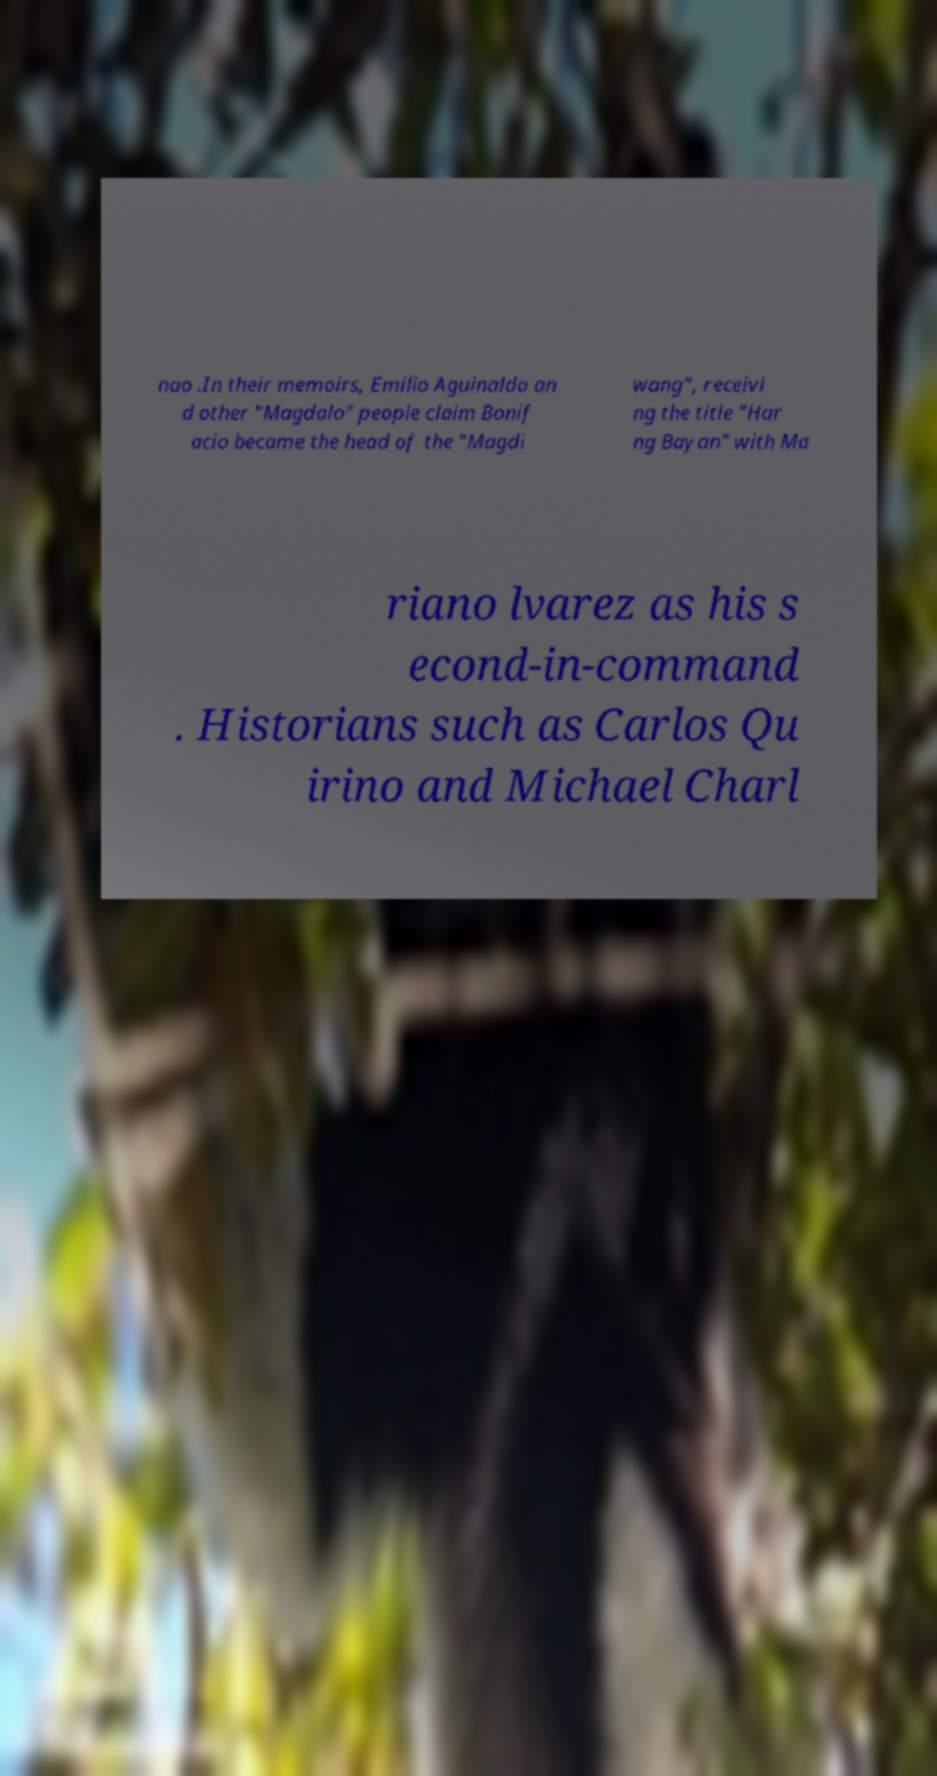What messages or text are displayed in this image? I need them in a readable, typed format. nao .In their memoirs, Emilio Aguinaldo an d other "Magdalo" people claim Bonif acio became the head of the "Magdi wang", receivi ng the title "Har ng Bayan" with Ma riano lvarez as his s econd-in-command . Historians such as Carlos Qu irino and Michael Charl 